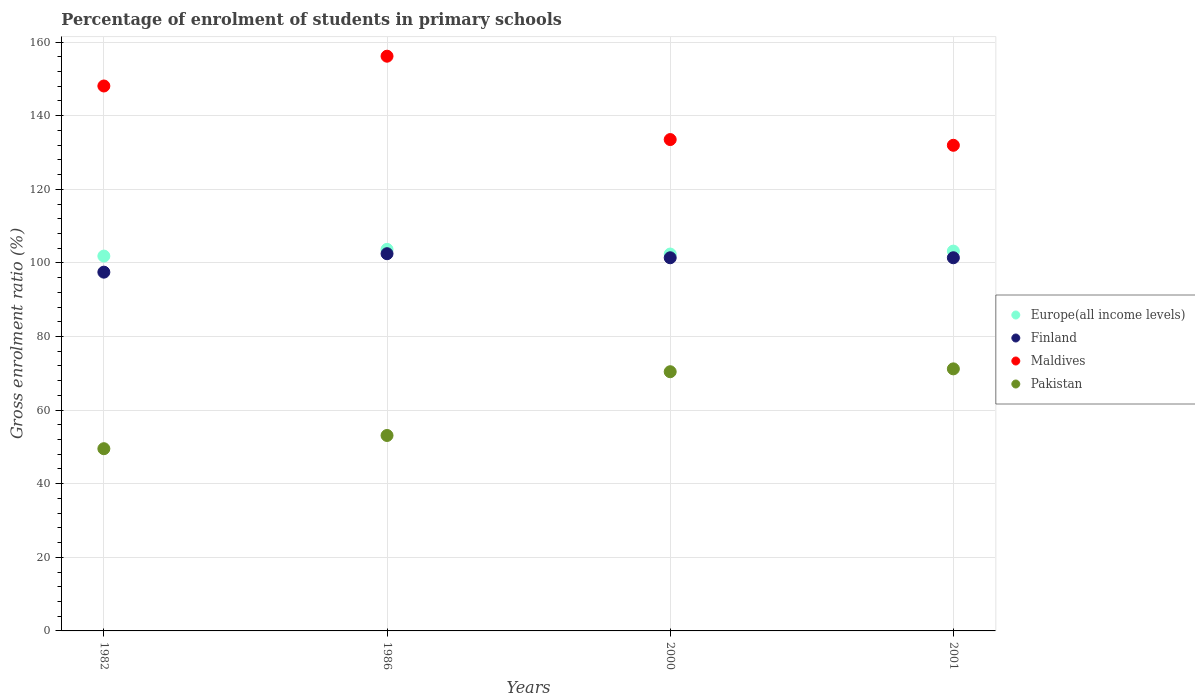How many different coloured dotlines are there?
Make the answer very short. 4. What is the percentage of students enrolled in primary schools in Pakistan in 1982?
Provide a succinct answer. 49.52. Across all years, what is the maximum percentage of students enrolled in primary schools in Maldives?
Provide a short and direct response. 156.17. Across all years, what is the minimum percentage of students enrolled in primary schools in Europe(all income levels)?
Offer a very short reply. 101.86. In which year was the percentage of students enrolled in primary schools in Maldives maximum?
Keep it short and to the point. 1986. In which year was the percentage of students enrolled in primary schools in Finland minimum?
Your answer should be compact. 1982. What is the total percentage of students enrolled in primary schools in Finland in the graph?
Provide a succinct answer. 402.79. What is the difference between the percentage of students enrolled in primary schools in Finland in 1986 and that in 2001?
Your response must be concise. 1.1. What is the difference between the percentage of students enrolled in primary schools in Europe(all income levels) in 2000 and the percentage of students enrolled in primary schools in Finland in 1982?
Provide a short and direct response. 4.92. What is the average percentage of students enrolled in primary schools in Finland per year?
Ensure brevity in your answer.  100.7. In the year 1986, what is the difference between the percentage of students enrolled in primary schools in Maldives and percentage of students enrolled in primary schools in Finland?
Your response must be concise. 53.67. What is the ratio of the percentage of students enrolled in primary schools in Pakistan in 1986 to that in 2001?
Give a very brief answer. 0.75. What is the difference between the highest and the second highest percentage of students enrolled in primary schools in Pakistan?
Provide a short and direct response. 0.78. What is the difference between the highest and the lowest percentage of students enrolled in primary schools in Finland?
Make the answer very short. 5.01. In how many years, is the percentage of students enrolled in primary schools in Maldives greater than the average percentage of students enrolled in primary schools in Maldives taken over all years?
Offer a very short reply. 2. Is the sum of the percentage of students enrolled in primary schools in Pakistan in 1982 and 1986 greater than the maximum percentage of students enrolled in primary schools in Maldives across all years?
Offer a terse response. No. Does the percentage of students enrolled in primary schools in Pakistan monotonically increase over the years?
Your response must be concise. Yes. How many dotlines are there?
Offer a terse response. 4. Does the graph contain grids?
Give a very brief answer. Yes. What is the title of the graph?
Your answer should be compact. Percentage of enrolment of students in primary schools. Does "Puerto Rico" appear as one of the legend labels in the graph?
Ensure brevity in your answer.  No. What is the Gross enrolment ratio (%) in Europe(all income levels) in 1982?
Ensure brevity in your answer.  101.86. What is the Gross enrolment ratio (%) in Finland in 1982?
Your answer should be compact. 97.49. What is the Gross enrolment ratio (%) of Maldives in 1982?
Your answer should be compact. 148.08. What is the Gross enrolment ratio (%) in Pakistan in 1982?
Your answer should be very brief. 49.52. What is the Gross enrolment ratio (%) in Europe(all income levels) in 1986?
Ensure brevity in your answer.  103.68. What is the Gross enrolment ratio (%) of Finland in 1986?
Offer a terse response. 102.5. What is the Gross enrolment ratio (%) in Maldives in 1986?
Ensure brevity in your answer.  156.17. What is the Gross enrolment ratio (%) of Pakistan in 1986?
Make the answer very short. 53.11. What is the Gross enrolment ratio (%) of Europe(all income levels) in 2000?
Offer a very short reply. 102.41. What is the Gross enrolment ratio (%) in Finland in 2000?
Your answer should be compact. 101.4. What is the Gross enrolment ratio (%) of Maldives in 2000?
Your answer should be compact. 133.52. What is the Gross enrolment ratio (%) in Pakistan in 2000?
Provide a short and direct response. 70.43. What is the Gross enrolment ratio (%) of Europe(all income levels) in 2001?
Provide a succinct answer. 103.21. What is the Gross enrolment ratio (%) of Finland in 2001?
Your answer should be compact. 101.4. What is the Gross enrolment ratio (%) in Maldives in 2001?
Offer a very short reply. 131.96. What is the Gross enrolment ratio (%) in Pakistan in 2001?
Give a very brief answer. 71.21. Across all years, what is the maximum Gross enrolment ratio (%) of Europe(all income levels)?
Offer a terse response. 103.68. Across all years, what is the maximum Gross enrolment ratio (%) in Finland?
Ensure brevity in your answer.  102.5. Across all years, what is the maximum Gross enrolment ratio (%) in Maldives?
Offer a very short reply. 156.17. Across all years, what is the maximum Gross enrolment ratio (%) of Pakistan?
Your response must be concise. 71.21. Across all years, what is the minimum Gross enrolment ratio (%) of Europe(all income levels)?
Ensure brevity in your answer.  101.86. Across all years, what is the minimum Gross enrolment ratio (%) of Finland?
Offer a very short reply. 97.49. Across all years, what is the minimum Gross enrolment ratio (%) in Maldives?
Offer a terse response. 131.96. Across all years, what is the minimum Gross enrolment ratio (%) in Pakistan?
Make the answer very short. 49.52. What is the total Gross enrolment ratio (%) of Europe(all income levels) in the graph?
Your answer should be compact. 411.16. What is the total Gross enrolment ratio (%) in Finland in the graph?
Provide a short and direct response. 402.79. What is the total Gross enrolment ratio (%) in Maldives in the graph?
Your answer should be compact. 569.73. What is the total Gross enrolment ratio (%) in Pakistan in the graph?
Your answer should be very brief. 244.27. What is the difference between the Gross enrolment ratio (%) of Europe(all income levels) in 1982 and that in 1986?
Offer a terse response. -1.83. What is the difference between the Gross enrolment ratio (%) of Finland in 1982 and that in 1986?
Your response must be concise. -5.01. What is the difference between the Gross enrolment ratio (%) in Maldives in 1982 and that in 1986?
Your answer should be compact. -8.09. What is the difference between the Gross enrolment ratio (%) in Pakistan in 1982 and that in 1986?
Offer a terse response. -3.59. What is the difference between the Gross enrolment ratio (%) of Europe(all income levels) in 1982 and that in 2000?
Your answer should be compact. -0.55. What is the difference between the Gross enrolment ratio (%) in Finland in 1982 and that in 2000?
Ensure brevity in your answer.  -3.91. What is the difference between the Gross enrolment ratio (%) in Maldives in 1982 and that in 2000?
Provide a short and direct response. 14.56. What is the difference between the Gross enrolment ratio (%) of Pakistan in 1982 and that in 2000?
Offer a terse response. -20.92. What is the difference between the Gross enrolment ratio (%) in Europe(all income levels) in 1982 and that in 2001?
Make the answer very short. -1.35. What is the difference between the Gross enrolment ratio (%) of Finland in 1982 and that in 2001?
Provide a succinct answer. -3.91. What is the difference between the Gross enrolment ratio (%) in Maldives in 1982 and that in 2001?
Offer a very short reply. 16.11. What is the difference between the Gross enrolment ratio (%) of Pakistan in 1982 and that in 2001?
Your answer should be very brief. -21.69. What is the difference between the Gross enrolment ratio (%) of Europe(all income levels) in 1986 and that in 2000?
Your answer should be compact. 1.27. What is the difference between the Gross enrolment ratio (%) of Finland in 1986 and that in 2000?
Make the answer very short. 1.1. What is the difference between the Gross enrolment ratio (%) in Maldives in 1986 and that in 2000?
Give a very brief answer. 22.65. What is the difference between the Gross enrolment ratio (%) in Pakistan in 1986 and that in 2000?
Keep it short and to the point. -17.32. What is the difference between the Gross enrolment ratio (%) in Europe(all income levels) in 1986 and that in 2001?
Your answer should be very brief. 0.47. What is the difference between the Gross enrolment ratio (%) in Finland in 1986 and that in 2001?
Offer a very short reply. 1.1. What is the difference between the Gross enrolment ratio (%) in Maldives in 1986 and that in 2001?
Keep it short and to the point. 24.21. What is the difference between the Gross enrolment ratio (%) of Pakistan in 1986 and that in 2001?
Ensure brevity in your answer.  -18.1. What is the difference between the Gross enrolment ratio (%) in Europe(all income levels) in 2000 and that in 2001?
Your response must be concise. -0.8. What is the difference between the Gross enrolment ratio (%) of Finland in 2000 and that in 2001?
Keep it short and to the point. -0. What is the difference between the Gross enrolment ratio (%) in Maldives in 2000 and that in 2001?
Offer a very short reply. 1.56. What is the difference between the Gross enrolment ratio (%) in Pakistan in 2000 and that in 2001?
Offer a very short reply. -0.78. What is the difference between the Gross enrolment ratio (%) of Europe(all income levels) in 1982 and the Gross enrolment ratio (%) of Finland in 1986?
Your response must be concise. -0.65. What is the difference between the Gross enrolment ratio (%) in Europe(all income levels) in 1982 and the Gross enrolment ratio (%) in Maldives in 1986?
Your answer should be compact. -54.31. What is the difference between the Gross enrolment ratio (%) of Europe(all income levels) in 1982 and the Gross enrolment ratio (%) of Pakistan in 1986?
Make the answer very short. 48.75. What is the difference between the Gross enrolment ratio (%) in Finland in 1982 and the Gross enrolment ratio (%) in Maldives in 1986?
Provide a succinct answer. -58.68. What is the difference between the Gross enrolment ratio (%) of Finland in 1982 and the Gross enrolment ratio (%) of Pakistan in 1986?
Your answer should be very brief. 44.38. What is the difference between the Gross enrolment ratio (%) in Maldives in 1982 and the Gross enrolment ratio (%) in Pakistan in 1986?
Offer a terse response. 94.97. What is the difference between the Gross enrolment ratio (%) of Europe(all income levels) in 1982 and the Gross enrolment ratio (%) of Finland in 2000?
Make the answer very short. 0.46. What is the difference between the Gross enrolment ratio (%) in Europe(all income levels) in 1982 and the Gross enrolment ratio (%) in Maldives in 2000?
Your answer should be very brief. -31.66. What is the difference between the Gross enrolment ratio (%) in Europe(all income levels) in 1982 and the Gross enrolment ratio (%) in Pakistan in 2000?
Keep it short and to the point. 31.42. What is the difference between the Gross enrolment ratio (%) in Finland in 1982 and the Gross enrolment ratio (%) in Maldives in 2000?
Give a very brief answer. -36.03. What is the difference between the Gross enrolment ratio (%) in Finland in 1982 and the Gross enrolment ratio (%) in Pakistan in 2000?
Offer a very short reply. 27.05. What is the difference between the Gross enrolment ratio (%) in Maldives in 1982 and the Gross enrolment ratio (%) in Pakistan in 2000?
Your answer should be very brief. 77.64. What is the difference between the Gross enrolment ratio (%) of Europe(all income levels) in 1982 and the Gross enrolment ratio (%) of Finland in 2001?
Your response must be concise. 0.46. What is the difference between the Gross enrolment ratio (%) in Europe(all income levels) in 1982 and the Gross enrolment ratio (%) in Maldives in 2001?
Make the answer very short. -30.11. What is the difference between the Gross enrolment ratio (%) of Europe(all income levels) in 1982 and the Gross enrolment ratio (%) of Pakistan in 2001?
Give a very brief answer. 30.65. What is the difference between the Gross enrolment ratio (%) of Finland in 1982 and the Gross enrolment ratio (%) of Maldives in 2001?
Offer a very short reply. -34.48. What is the difference between the Gross enrolment ratio (%) in Finland in 1982 and the Gross enrolment ratio (%) in Pakistan in 2001?
Ensure brevity in your answer.  26.28. What is the difference between the Gross enrolment ratio (%) of Maldives in 1982 and the Gross enrolment ratio (%) of Pakistan in 2001?
Provide a succinct answer. 76.87. What is the difference between the Gross enrolment ratio (%) in Europe(all income levels) in 1986 and the Gross enrolment ratio (%) in Finland in 2000?
Make the answer very short. 2.28. What is the difference between the Gross enrolment ratio (%) in Europe(all income levels) in 1986 and the Gross enrolment ratio (%) in Maldives in 2000?
Make the answer very short. -29.84. What is the difference between the Gross enrolment ratio (%) of Europe(all income levels) in 1986 and the Gross enrolment ratio (%) of Pakistan in 2000?
Keep it short and to the point. 33.25. What is the difference between the Gross enrolment ratio (%) of Finland in 1986 and the Gross enrolment ratio (%) of Maldives in 2000?
Offer a terse response. -31.02. What is the difference between the Gross enrolment ratio (%) in Finland in 1986 and the Gross enrolment ratio (%) in Pakistan in 2000?
Your answer should be compact. 32.07. What is the difference between the Gross enrolment ratio (%) of Maldives in 1986 and the Gross enrolment ratio (%) of Pakistan in 2000?
Provide a succinct answer. 85.74. What is the difference between the Gross enrolment ratio (%) in Europe(all income levels) in 1986 and the Gross enrolment ratio (%) in Finland in 2001?
Offer a very short reply. 2.28. What is the difference between the Gross enrolment ratio (%) of Europe(all income levels) in 1986 and the Gross enrolment ratio (%) of Maldives in 2001?
Keep it short and to the point. -28.28. What is the difference between the Gross enrolment ratio (%) of Europe(all income levels) in 1986 and the Gross enrolment ratio (%) of Pakistan in 2001?
Give a very brief answer. 32.47. What is the difference between the Gross enrolment ratio (%) of Finland in 1986 and the Gross enrolment ratio (%) of Maldives in 2001?
Make the answer very short. -29.46. What is the difference between the Gross enrolment ratio (%) of Finland in 1986 and the Gross enrolment ratio (%) of Pakistan in 2001?
Ensure brevity in your answer.  31.29. What is the difference between the Gross enrolment ratio (%) of Maldives in 1986 and the Gross enrolment ratio (%) of Pakistan in 2001?
Give a very brief answer. 84.96. What is the difference between the Gross enrolment ratio (%) in Europe(all income levels) in 2000 and the Gross enrolment ratio (%) in Finland in 2001?
Offer a terse response. 1.01. What is the difference between the Gross enrolment ratio (%) of Europe(all income levels) in 2000 and the Gross enrolment ratio (%) of Maldives in 2001?
Provide a short and direct response. -29.55. What is the difference between the Gross enrolment ratio (%) in Europe(all income levels) in 2000 and the Gross enrolment ratio (%) in Pakistan in 2001?
Your answer should be compact. 31.2. What is the difference between the Gross enrolment ratio (%) of Finland in 2000 and the Gross enrolment ratio (%) of Maldives in 2001?
Ensure brevity in your answer.  -30.56. What is the difference between the Gross enrolment ratio (%) in Finland in 2000 and the Gross enrolment ratio (%) in Pakistan in 2001?
Provide a succinct answer. 30.19. What is the difference between the Gross enrolment ratio (%) in Maldives in 2000 and the Gross enrolment ratio (%) in Pakistan in 2001?
Keep it short and to the point. 62.31. What is the average Gross enrolment ratio (%) of Europe(all income levels) per year?
Offer a very short reply. 102.79. What is the average Gross enrolment ratio (%) in Finland per year?
Provide a short and direct response. 100.7. What is the average Gross enrolment ratio (%) in Maldives per year?
Your response must be concise. 142.43. What is the average Gross enrolment ratio (%) in Pakistan per year?
Your answer should be compact. 61.07. In the year 1982, what is the difference between the Gross enrolment ratio (%) of Europe(all income levels) and Gross enrolment ratio (%) of Finland?
Provide a short and direct response. 4.37. In the year 1982, what is the difference between the Gross enrolment ratio (%) in Europe(all income levels) and Gross enrolment ratio (%) in Maldives?
Your answer should be compact. -46.22. In the year 1982, what is the difference between the Gross enrolment ratio (%) in Europe(all income levels) and Gross enrolment ratio (%) in Pakistan?
Make the answer very short. 52.34. In the year 1982, what is the difference between the Gross enrolment ratio (%) in Finland and Gross enrolment ratio (%) in Maldives?
Your response must be concise. -50.59. In the year 1982, what is the difference between the Gross enrolment ratio (%) of Finland and Gross enrolment ratio (%) of Pakistan?
Provide a succinct answer. 47.97. In the year 1982, what is the difference between the Gross enrolment ratio (%) in Maldives and Gross enrolment ratio (%) in Pakistan?
Your answer should be compact. 98.56. In the year 1986, what is the difference between the Gross enrolment ratio (%) in Europe(all income levels) and Gross enrolment ratio (%) in Finland?
Your answer should be compact. 1.18. In the year 1986, what is the difference between the Gross enrolment ratio (%) in Europe(all income levels) and Gross enrolment ratio (%) in Maldives?
Keep it short and to the point. -52.49. In the year 1986, what is the difference between the Gross enrolment ratio (%) of Europe(all income levels) and Gross enrolment ratio (%) of Pakistan?
Provide a short and direct response. 50.57. In the year 1986, what is the difference between the Gross enrolment ratio (%) of Finland and Gross enrolment ratio (%) of Maldives?
Keep it short and to the point. -53.67. In the year 1986, what is the difference between the Gross enrolment ratio (%) in Finland and Gross enrolment ratio (%) in Pakistan?
Provide a succinct answer. 49.39. In the year 1986, what is the difference between the Gross enrolment ratio (%) of Maldives and Gross enrolment ratio (%) of Pakistan?
Make the answer very short. 103.06. In the year 2000, what is the difference between the Gross enrolment ratio (%) of Europe(all income levels) and Gross enrolment ratio (%) of Finland?
Give a very brief answer. 1.01. In the year 2000, what is the difference between the Gross enrolment ratio (%) in Europe(all income levels) and Gross enrolment ratio (%) in Maldives?
Your response must be concise. -31.11. In the year 2000, what is the difference between the Gross enrolment ratio (%) of Europe(all income levels) and Gross enrolment ratio (%) of Pakistan?
Your answer should be very brief. 31.98. In the year 2000, what is the difference between the Gross enrolment ratio (%) in Finland and Gross enrolment ratio (%) in Maldives?
Provide a succinct answer. -32.12. In the year 2000, what is the difference between the Gross enrolment ratio (%) of Finland and Gross enrolment ratio (%) of Pakistan?
Make the answer very short. 30.96. In the year 2000, what is the difference between the Gross enrolment ratio (%) in Maldives and Gross enrolment ratio (%) in Pakistan?
Ensure brevity in your answer.  63.09. In the year 2001, what is the difference between the Gross enrolment ratio (%) in Europe(all income levels) and Gross enrolment ratio (%) in Finland?
Offer a very short reply. 1.81. In the year 2001, what is the difference between the Gross enrolment ratio (%) of Europe(all income levels) and Gross enrolment ratio (%) of Maldives?
Provide a succinct answer. -28.75. In the year 2001, what is the difference between the Gross enrolment ratio (%) in Europe(all income levels) and Gross enrolment ratio (%) in Pakistan?
Your response must be concise. 32. In the year 2001, what is the difference between the Gross enrolment ratio (%) of Finland and Gross enrolment ratio (%) of Maldives?
Your response must be concise. -30.56. In the year 2001, what is the difference between the Gross enrolment ratio (%) in Finland and Gross enrolment ratio (%) in Pakistan?
Your answer should be compact. 30.19. In the year 2001, what is the difference between the Gross enrolment ratio (%) in Maldives and Gross enrolment ratio (%) in Pakistan?
Provide a succinct answer. 60.75. What is the ratio of the Gross enrolment ratio (%) of Europe(all income levels) in 1982 to that in 1986?
Your answer should be compact. 0.98. What is the ratio of the Gross enrolment ratio (%) in Finland in 1982 to that in 1986?
Offer a very short reply. 0.95. What is the ratio of the Gross enrolment ratio (%) in Maldives in 1982 to that in 1986?
Offer a very short reply. 0.95. What is the ratio of the Gross enrolment ratio (%) in Pakistan in 1982 to that in 1986?
Keep it short and to the point. 0.93. What is the ratio of the Gross enrolment ratio (%) in Finland in 1982 to that in 2000?
Ensure brevity in your answer.  0.96. What is the ratio of the Gross enrolment ratio (%) in Maldives in 1982 to that in 2000?
Ensure brevity in your answer.  1.11. What is the ratio of the Gross enrolment ratio (%) of Pakistan in 1982 to that in 2000?
Provide a succinct answer. 0.7. What is the ratio of the Gross enrolment ratio (%) in Europe(all income levels) in 1982 to that in 2001?
Your answer should be very brief. 0.99. What is the ratio of the Gross enrolment ratio (%) of Finland in 1982 to that in 2001?
Provide a succinct answer. 0.96. What is the ratio of the Gross enrolment ratio (%) of Maldives in 1982 to that in 2001?
Ensure brevity in your answer.  1.12. What is the ratio of the Gross enrolment ratio (%) of Pakistan in 1982 to that in 2001?
Your response must be concise. 0.7. What is the ratio of the Gross enrolment ratio (%) in Europe(all income levels) in 1986 to that in 2000?
Your answer should be very brief. 1.01. What is the ratio of the Gross enrolment ratio (%) of Finland in 1986 to that in 2000?
Give a very brief answer. 1.01. What is the ratio of the Gross enrolment ratio (%) of Maldives in 1986 to that in 2000?
Provide a succinct answer. 1.17. What is the ratio of the Gross enrolment ratio (%) in Pakistan in 1986 to that in 2000?
Offer a terse response. 0.75. What is the ratio of the Gross enrolment ratio (%) of Finland in 1986 to that in 2001?
Your answer should be compact. 1.01. What is the ratio of the Gross enrolment ratio (%) in Maldives in 1986 to that in 2001?
Your answer should be compact. 1.18. What is the ratio of the Gross enrolment ratio (%) in Pakistan in 1986 to that in 2001?
Ensure brevity in your answer.  0.75. What is the ratio of the Gross enrolment ratio (%) in Europe(all income levels) in 2000 to that in 2001?
Give a very brief answer. 0.99. What is the ratio of the Gross enrolment ratio (%) of Maldives in 2000 to that in 2001?
Make the answer very short. 1.01. What is the ratio of the Gross enrolment ratio (%) of Pakistan in 2000 to that in 2001?
Offer a very short reply. 0.99. What is the difference between the highest and the second highest Gross enrolment ratio (%) in Europe(all income levels)?
Give a very brief answer. 0.47. What is the difference between the highest and the second highest Gross enrolment ratio (%) of Finland?
Give a very brief answer. 1.1. What is the difference between the highest and the second highest Gross enrolment ratio (%) in Maldives?
Ensure brevity in your answer.  8.09. What is the difference between the highest and the second highest Gross enrolment ratio (%) of Pakistan?
Ensure brevity in your answer.  0.78. What is the difference between the highest and the lowest Gross enrolment ratio (%) in Europe(all income levels)?
Provide a succinct answer. 1.83. What is the difference between the highest and the lowest Gross enrolment ratio (%) of Finland?
Your answer should be very brief. 5.01. What is the difference between the highest and the lowest Gross enrolment ratio (%) in Maldives?
Your response must be concise. 24.21. What is the difference between the highest and the lowest Gross enrolment ratio (%) of Pakistan?
Make the answer very short. 21.69. 